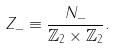<formula> <loc_0><loc_0><loc_500><loc_500>Z _ { - } \equiv \frac { N _ { - } } { \mathbb { Z } _ { 2 } \times \mathbb { Z } _ { 2 } } .</formula> 